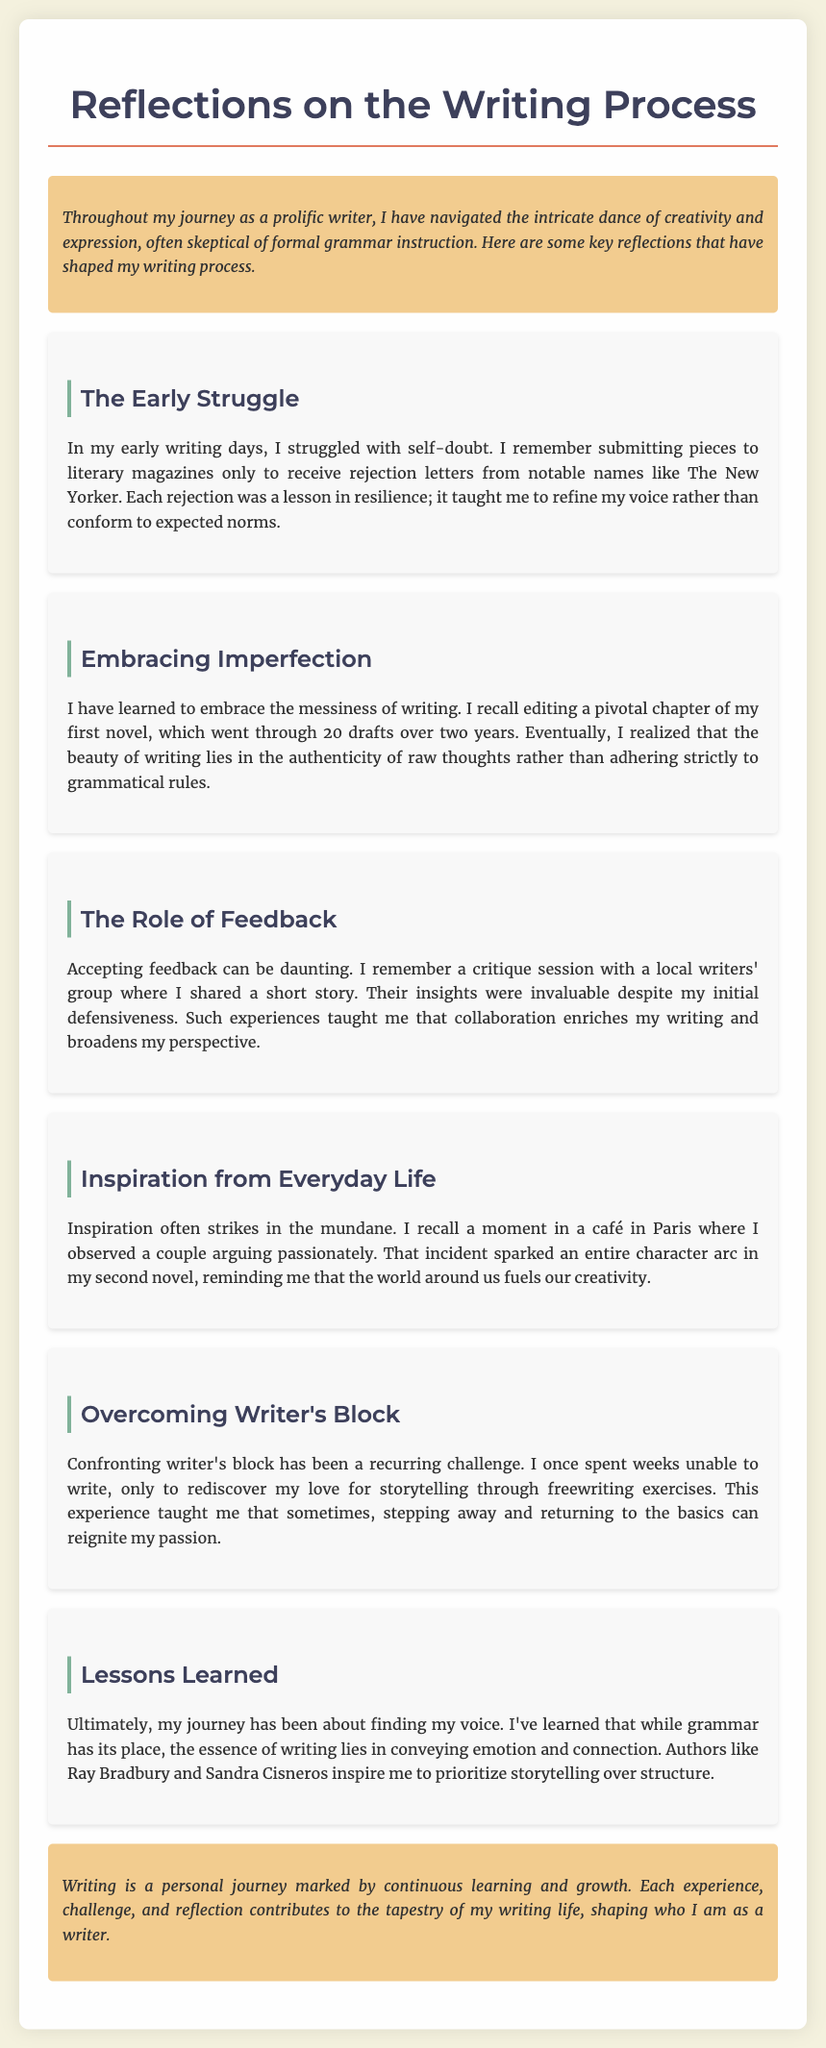What is the title of the document? The title is explicitly stated in the heading of the document.
Answer: Reflections on the Writing Process How many drafts did the author complete for a pivotal chapter of their first novel? The author mentions a specific number of drafts completed during the writing process of the chapter.
Answer: 20 drafts What did the author struggle with in their early writing days? The author describes a specific challenge they faced as a writer, focusing on internal feelings.
Answer: Self-doubt Where did the author find inspiration for a character arc in their second novel? The author provides a location context where inspiration struck for their writing.
Answer: A café in Paris Who are two authors mentioned as inspirations to the author? The document lists notable authors who have influenced the author's writing journey.
Answer: Ray Bradbury and Sandra Cisneros What lesson did the author learn from confronting writer's block? The author reflects on a particular insight gained from overcoming a writing challenge.
Answer: Rediscovering love for storytelling What type of group did the author share their short story with? The author mentions a specific setting where they sought feedback on their writing.
Answer: Local writers' group What is emphasized as more important than grammatical structure according to the author? The author expresses a philosophical view regarding storytelling in relation to writing.
Answer: Conveying emotion and connection 